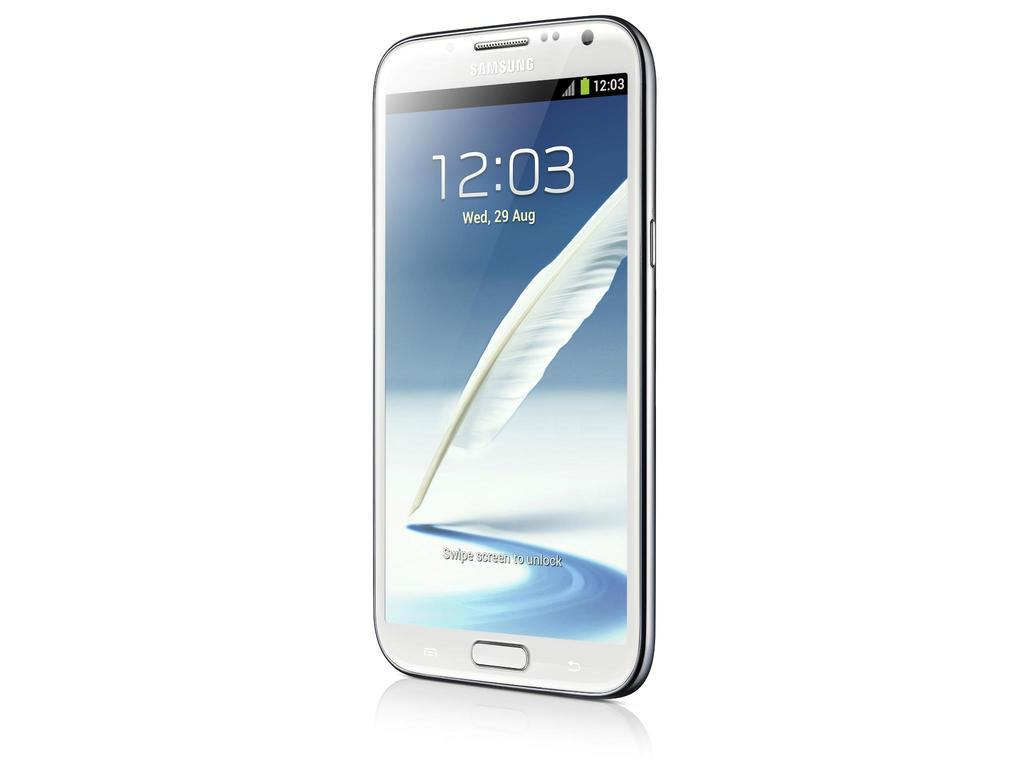Provide a one-sentence caption for the provided image. a phone with the time 12:03 on the screen. 